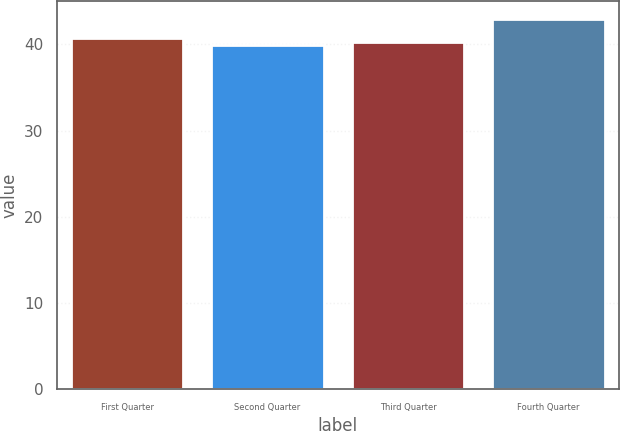Convert chart to OTSL. <chart><loc_0><loc_0><loc_500><loc_500><bar_chart><fcel>First Quarter<fcel>Second Quarter<fcel>Third Quarter<fcel>Fourth Quarter<nl><fcel>40.74<fcel>39.94<fcel>40.24<fcel>42.91<nl></chart> 